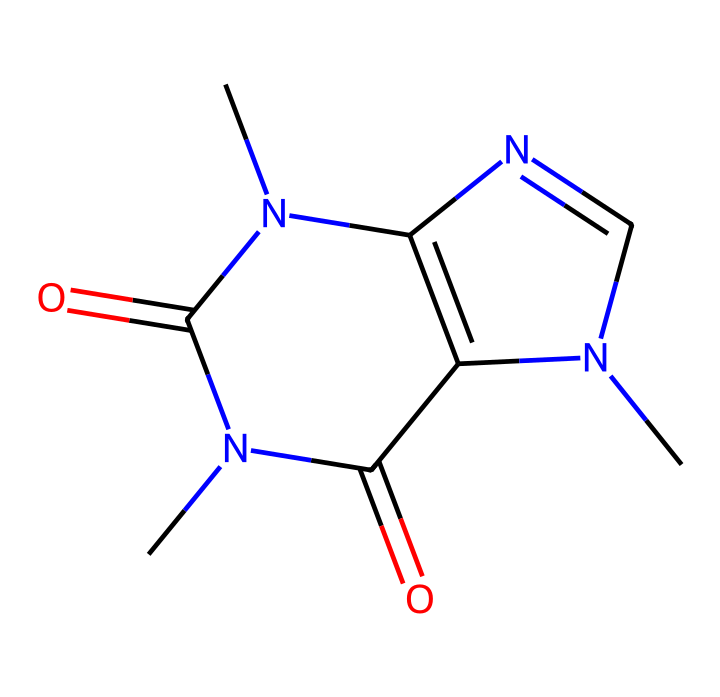What is the molecular formula of caffeine? To find the molecular formula, we observe the atoms represented in the SMILES. The breakdown shows there are 8 carbons (C), 10 hydrogens (H), 4 nitrogens (N), and 2 oxygens (O). Therefore, the complete molecular formula is C8H10N4O2.
Answer: C8H10N4O2 How many nitrogen atoms are present in caffeine? By analyzing the SMILES representation, we can identify that there are four nitrogen (N) atoms in the structure of caffeine.
Answer: 4 What type of chemical structure does caffeine represent? The structure of caffeine comprises a fused ring system typical for alkaloids, which contain nitrogen atoms and exhibit stimulant properties. Thus, caffeine is classified as an alkaloid.
Answer: alkaloid What is the total number of rings in the caffeine structure? In the provided SMILES, we notice that there are two fused ring structures. The numbering indicates that the chemical comprises one pyrimidine and one imidazole ring system. Thus, the total number of rings is two.
Answer: 2 How many carbon atoms are in the largest ring of caffeine? Examining the largest ring in caffeine, we find that it contains six carbon atoms. We can count the carbons that are part of this specific ring structure through the visual clues in the SMILES representation.
Answer: 6 Which functional groups are evident in the structure of caffeine? In caffeine's structure, the presence of carbonyl groups (C=O) and amine groups (N) indicates that it has ketone and amino functional groups. This suggests that caffeine has both carbonyl and amine functionalities.
Answer: carbonyl and amine 